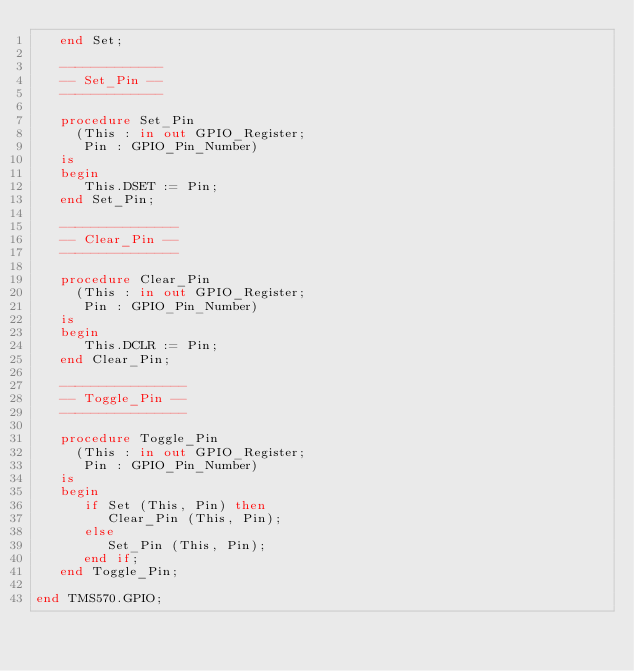<code> <loc_0><loc_0><loc_500><loc_500><_Ada_>   end Set;

   -------------
   -- Set_Pin --
   -------------

   procedure Set_Pin
     (This : in out GPIO_Register;
      Pin : GPIO_Pin_Number)
   is
   begin
      This.DSET := Pin;
   end Set_Pin;

   ---------------
   -- Clear_Pin --
   ---------------

   procedure Clear_Pin
     (This : in out GPIO_Register;
      Pin : GPIO_Pin_Number)
   is
   begin
      This.DCLR := Pin;
   end Clear_Pin;

   ----------------
   -- Toggle_Pin --
   ----------------

   procedure Toggle_Pin
     (This : in out GPIO_Register;
      Pin : GPIO_Pin_Number)
   is
   begin
      if Set (This, Pin) then
         Clear_Pin (This, Pin);
      else
         Set_Pin (This, Pin);
      end if;
   end Toggle_Pin;

end TMS570.GPIO;
</code> 